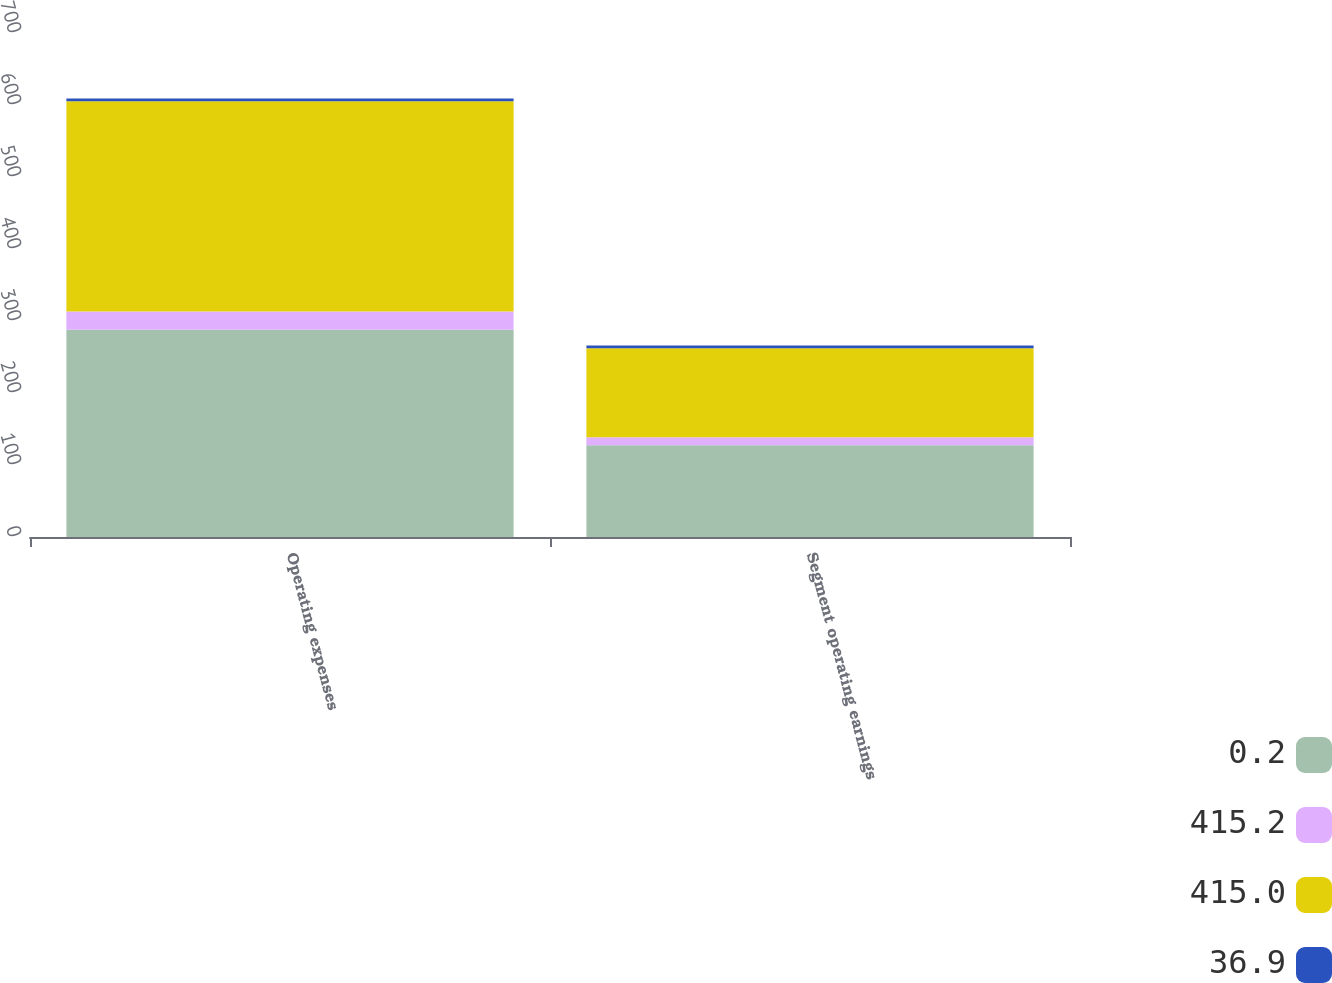<chart> <loc_0><loc_0><loc_500><loc_500><stacked_bar_chart><ecel><fcel>Operating expenses<fcel>Segment operating earnings<nl><fcel>0.2<fcel>287.7<fcel>127.3<nl><fcel>415.2<fcel>25.6<fcel>11.3<nl><fcel>415<fcel>291.8<fcel>123.4<nl><fcel>36.9<fcel>4.1<fcel>3.9<nl></chart> 